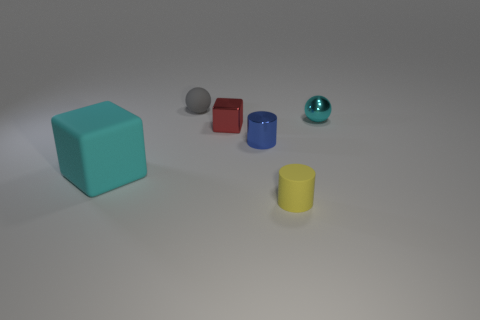What shape is the small metal object that is the same color as the large rubber object?
Provide a short and direct response. Sphere. There is a cyan shiny thing; how many gray rubber things are left of it?
Keep it short and to the point. 1. Does the small ball right of the shiny cylinder have the same color as the rubber cube?
Offer a very short reply. Yes. How many metal objects have the same size as the gray sphere?
Keep it short and to the point. 3. The large thing that is made of the same material as the gray ball is what shape?
Offer a terse response. Cube. Are there any metal spheres that have the same color as the large matte thing?
Ensure brevity in your answer.  Yes. What material is the yellow cylinder?
Give a very brief answer. Rubber. What number of objects are either small yellow matte cylinders or big gray metal balls?
Your response must be concise. 1. How big is the cyan cube in front of the tiny cyan ball?
Provide a short and direct response. Large. What number of other things are there of the same material as the yellow object
Your answer should be compact. 2. 